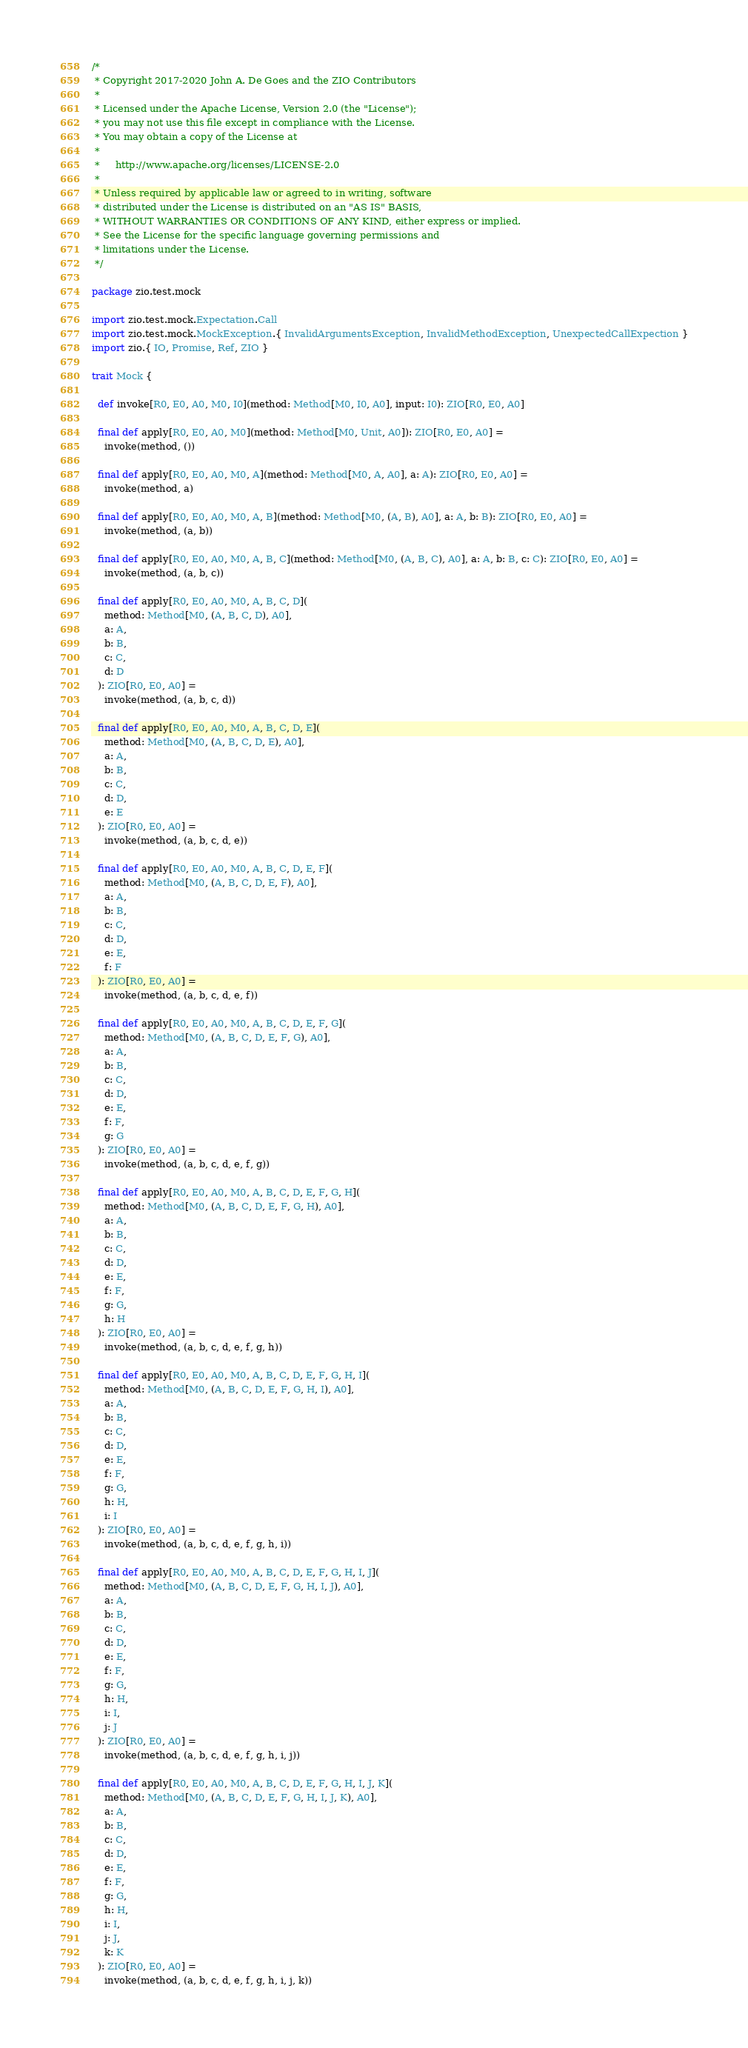Convert code to text. <code><loc_0><loc_0><loc_500><loc_500><_Scala_>/*
 * Copyright 2017-2020 John A. De Goes and the ZIO Contributors
 *
 * Licensed under the Apache License, Version 2.0 (the "License");
 * you may not use this file except in compliance with the License.
 * You may obtain a copy of the License at
 *
 *     http://www.apache.org/licenses/LICENSE-2.0
 *
 * Unless required by applicable law or agreed to in writing, software
 * distributed under the License is distributed on an "AS IS" BASIS,
 * WITHOUT WARRANTIES OR CONDITIONS OF ANY KIND, either express or implied.
 * See the License for the specific language governing permissions and
 * limitations under the License.
 */

package zio.test.mock

import zio.test.mock.Expectation.Call
import zio.test.mock.MockException.{ InvalidArgumentsException, InvalidMethodException, UnexpectedCallExpection }
import zio.{ IO, Promise, Ref, ZIO }

trait Mock {

  def invoke[R0, E0, A0, M0, I0](method: Method[M0, I0, A0], input: I0): ZIO[R0, E0, A0]

  final def apply[R0, E0, A0, M0](method: Method[M0, Unit, A0]): ZIO[R0, E0, A0] =
    invoke(method, ())

  final def apply[R0, E0, A0, M0, A](method: Method[M0, A, A0], a: A): ZIO[R0, E0, A0] =
    invoke(method, a)

  final def apply[R0, E0, A0, M0, A, B](method: Method[M0, (A, B), A0], a: A, b: B): ZIO[R0, E0, A0] =
    invoke(method, (a, b))

  final def apply[R0, E0, A0, M0, A, B, C](method: Method[M0, (A, B, C), A0], a: A, b: B, c: C): ZIO[R0, E0, A0] =
    invoke(method, (a, b, c))

  final def apply[R0, E0, A0, M0, A, B, C, D](
    method: Method[M0, (A, B, C, D), A0],
    a: A,
    b: B,
    c: C,
    d: D
  ): ZIO[R0, E0, A0] =
    invoke(method, (a, b, c, d))

  final def apply[R0, E0, A0, M0, A, B, C, D, E](
    method: Method[M0, (A, B, C, D, E), A0],
    a: A,
    b: B,
    c: C,
    d: D,
    e: E
  ): ZIO[R0, E0, A0] =
    invoke(method, (a, b, c, d, e))

  final def apply[R0, E0, A0, M0, A, B, C, D, E, F](
    method: Method[M0, (A, B, C, D, E, F), A0],
    a: A,
    b: B,
    c: C,
    d: D,
    e: E,
    f: F
  ): ZIO[R0, E0, A0] =
    invoke(method, (a, b, c, d, e, f))

  final def apply[R0, E0, A0, M0, A, B, C, D, E, F, G](
    method: Method[M0, (A, B, C, D, E, F, G), A0],
    a: A,
    b: B,
    c: C,
    d: D,
    e: E,
    f: F,
    g: G
  ): ZIO[R0, E0, A0] =
    invoke(method, (a, b, c, d, e, f, g))

  final def apply[R0, E0, A0, M0, A, B, C, D, E, F, G, H](
    method: Method[M0, (A, B, C, D, E, F, G, H), A0],
    a: A,
    b: B,
    c: C,
    d: D,
    e: E,
    f: F,
    g: G,
    h: H
  ): ZIO[R0, E0, A0] =
    invoke(method, (a, b, c, d, e, f, g, h))

  final def apply[R0, E0, A0, M0, A, B, C, D, E, F, G, H, I](
    method: Method[M0, (A, B, C, D, E, F, G, H, I), A0],
    a: A,
    b: B,
    c: C,
    d: D,
    e: E,
    f: F,
    g: G,
    h: H,
    i: I
  ): ZIO[R0, E0, A0] =
    invoke(method, (a, b, c, d, e, f, g, h, i))

  final def apply[R0, E0, A0, M0, A, B, C, D, E, F, G, H, I, J](
    method: Method[M0, (A, B, C, D, E, F, G, H, I, J), A0],
    a: A,
    b: B,
    c: C,
    d: D,
    e: E,
    f: F,
    g: G,
    h: H,
    i: I,
    j: J
  ): ZIO[R0, E0, A0] =
    invoke(method, (a, b, c, d, e, f, g, h, i, j))

  final def apply[R0, E0, A0, M0, A, B, C, D, E, F, G, H, I, J, K](
    method: Method[M0, (A, B, C, D, E, F, G, H, I, J, K), A0],
    a: A,
    b: B,
    c: C,
    d: D,
    e: E,
    f: F,
    g: G,
    h: H,
    i: I,
    j: J,
    k: K
  ): ZIO[R0, E0, A0] =
    invoke(method, (a, b, c, d, e, f, g, h, i, j, k))
</code> 